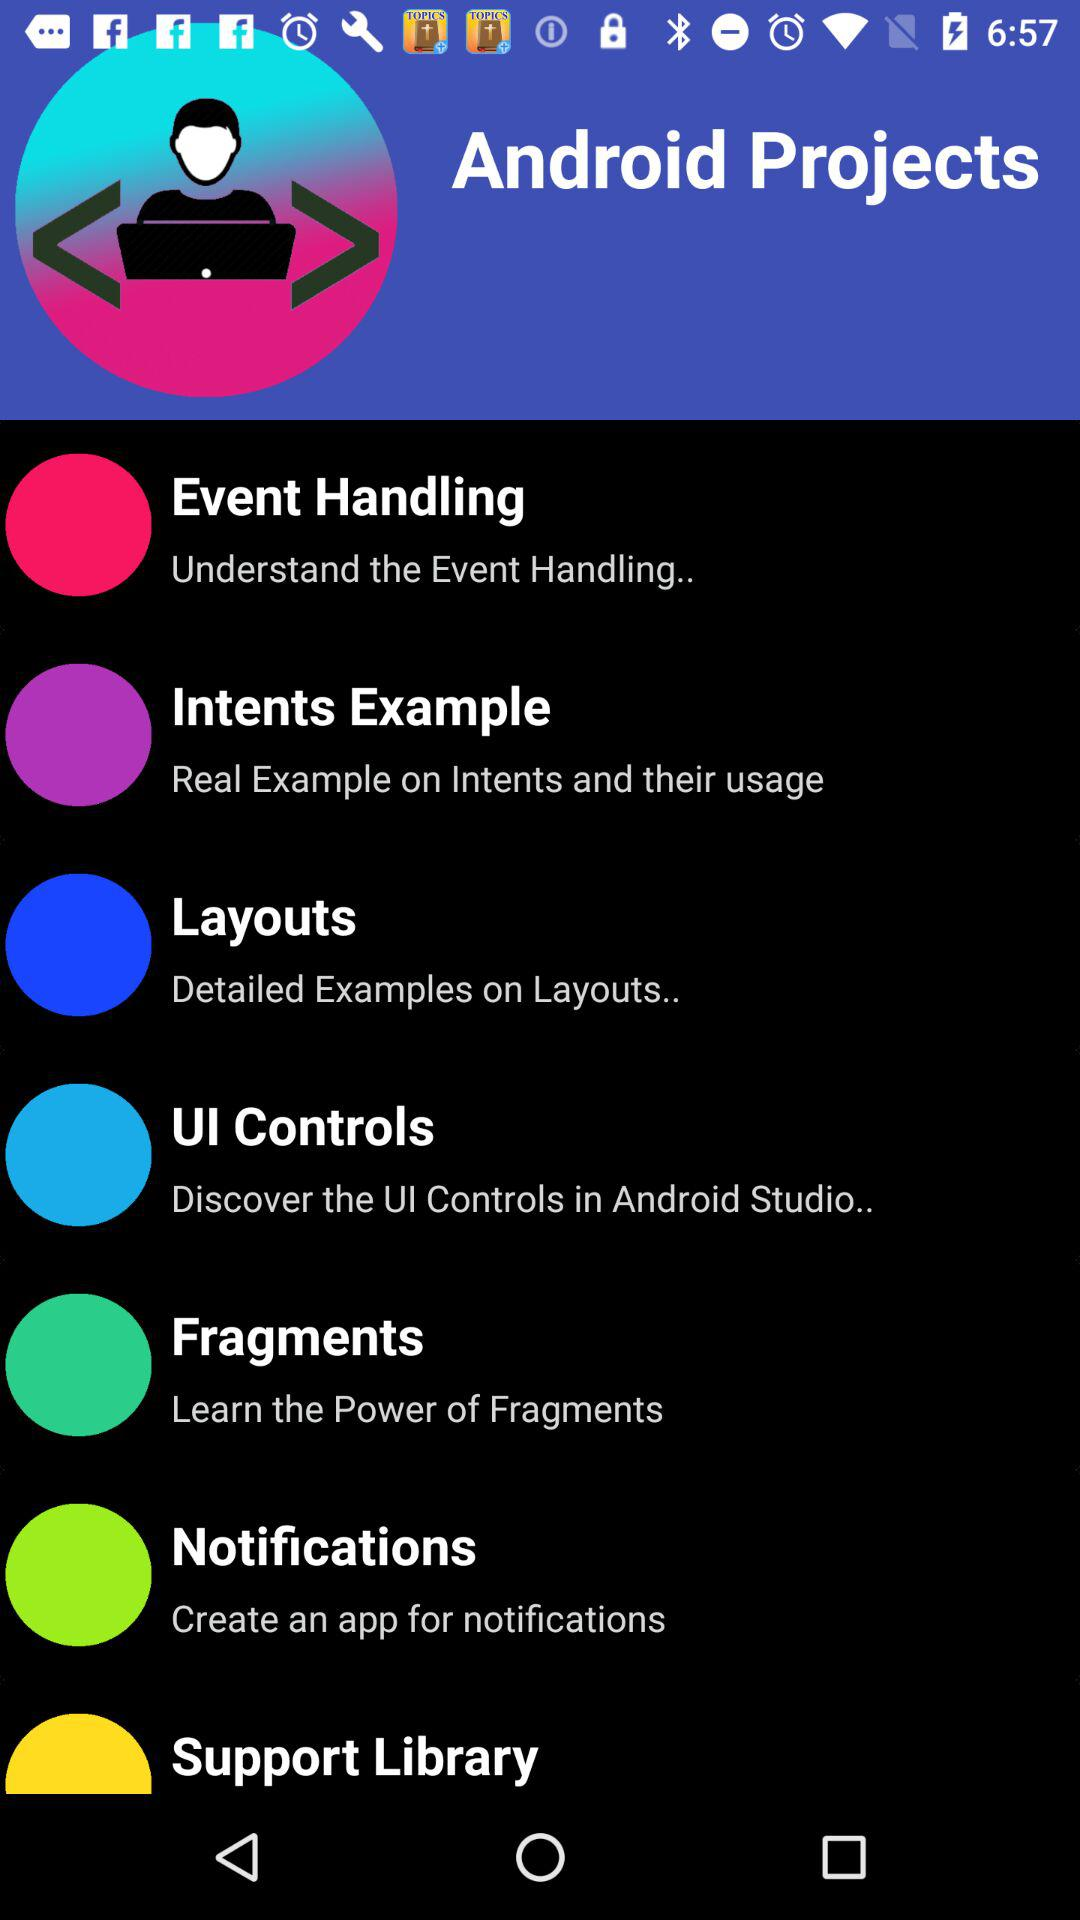What is the application name? The application name is "Android Projects". 